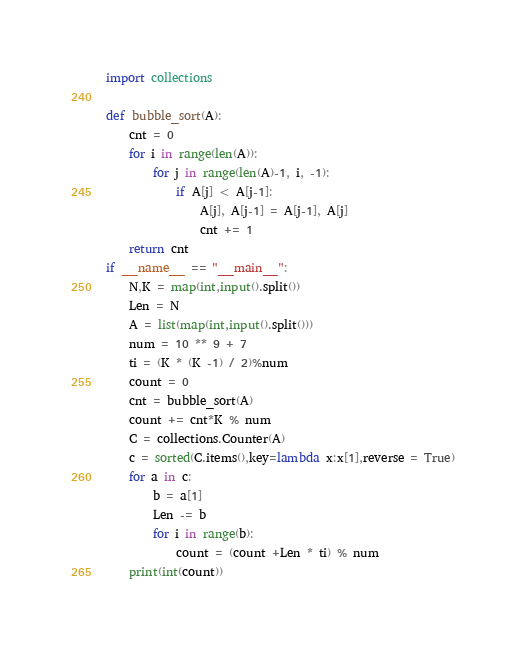Convert code to text. <code><loc_0><loc_0><loc_500><loc_500><_Python_>import collections

def bubble_sort(A):
    cnt = 0
    for i in range(len(A)):
        for j in range(len(A)-1, i, -1):
            if A[j] < A[j-1]:
                A[j], A[j-1] = A[j-1], A[j]
                cnt += 1
    return cnt
if __name__ == "__main__":
    N,K = map(int,input().split())
    Len = N
    A = list(map(int,input().split()))
    num = 10 ** 9 + 7
    ti = (K * (K -1) / 2)%num
    count = 0
    cnt = bubble_sort(A)
    count += cnt*K % num
    C = collections.Counter(A)
    c = sorted(C.items(),key=lambda x:x[1],reverse = True)
    for a in c:
        b = a[1]
        Len -= b
        for i in range(b):
            count = (count +Len * ti) % num
    print(int(count))</code> 